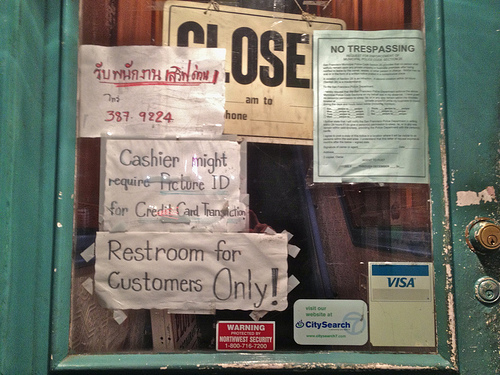<image>
Is there a sign in front of the door? No. The sign is not in front of the door. The spatial positioning shows a different relationship between these objects. 